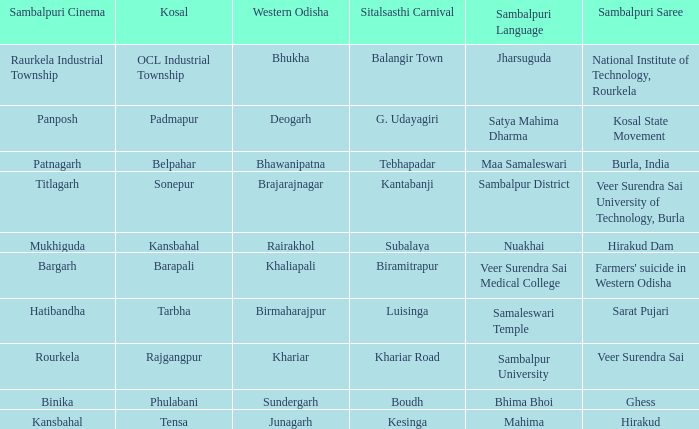What is the sitalsasthi carnival with hirakud as sambalpuri saree? Kesinga. 